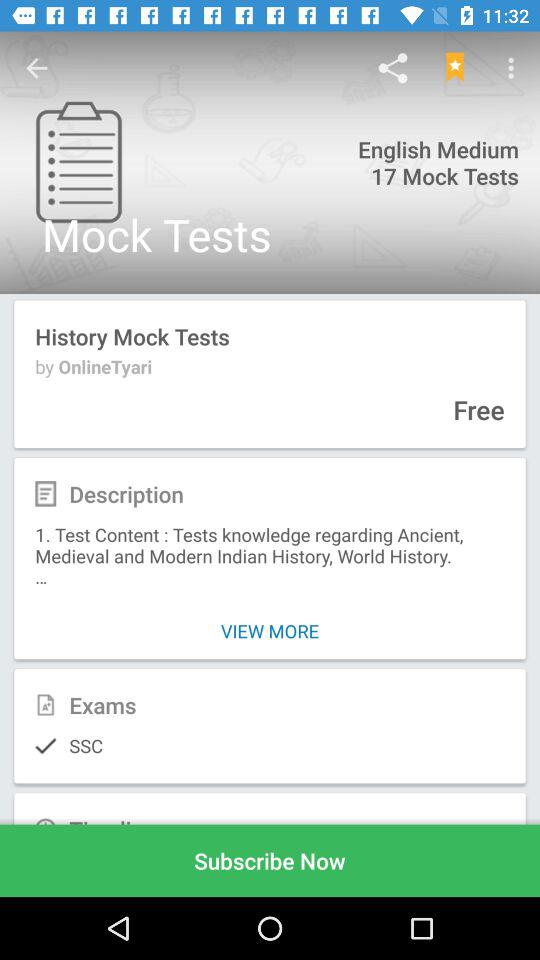What information will Onlinetyari receive? Onlinetyari will receive your public profile and email address. 